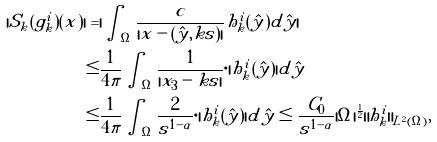<formula> <loc_0><loc_0><loc_500><loc_500>| S _ { k } ( g _ { k } ^ { i } ) ( x ) | = & | \int _ { \Omega } \frac { c } { | x - ( \hat { y } , k s ) | } h _ { k } ^ { i } ( \hat { y } ) d \hat { y } | \\ \leq & \frac { 1 } { 4 \pi } \int _ { \Omega } \frac { 1 } { | x _ { 3 } - k s | } \cdot | h _ { k } ^ { i } ( \hat { y } ) | d \hat { y } \\ \leq & \frac { 1 } { 4 \pi } \int _ { \Omega } \frac { 2 } { s ^ { 1 - \alpha } } \cdot | h _ { k } ^ { i } ( \hat { y } ) | d \hat { y } \leq \frac { C _ { 0 } } { s ^ { 1 - \alpha } } | \Omega | ^ { \frac { 1 } { 2 } } \| h _ { k } ^ { i } \| _ { L ^ { 2 } ( \Omega ) } ,</formula> 